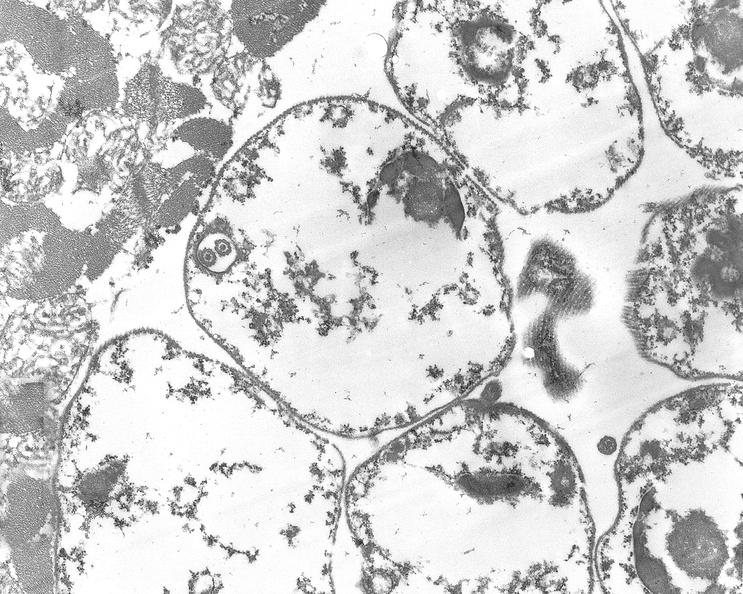where is this?
Answer the question using a single word or phrase. Heart 